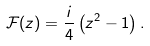<formula> <loc_0><loc_0><loc_500><loc_500>\mathcal { F } ( z ) = \frac { i } { 4 } \left ( z ^ { 2 } - 1 \right ) .</formula> 